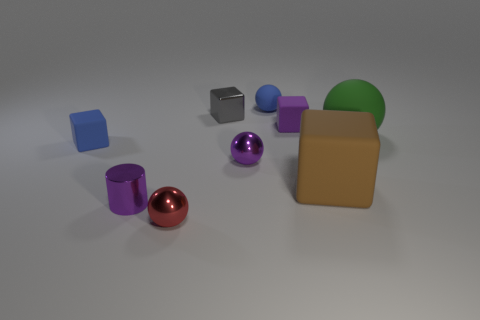Do the gray thing and the purple thing in front of the large brown cube have the same material?
Ensure brevity in your answer.  Yes. Are there fewer rubber cubes than purple matte things?
Keep it short and to the point. No. Is there any other thing that is the same color as the tiny metal cylinder?
Your answer should be very brief. Yes. What shape is the purple object that is the same material as the brown thing?
Offer a very short reply. Cube. There is a ball right of the rubber object that is in front of the purple ball; how many blue balls are in front of it?
Ensure brevity in your answer.  0. There is a rubber thing that is both in front of the green rubber ball and on the left side of the tiny purple rubber cube; what is its shape?
Give a very brief answer. Cube. Is the number of small purple matte cubes that are right of the green rubber thing less than the number of tiny green metal balls?
Provide a succinct answer. No. What number of large things are either brown metallic cylinders or red metal balls?
Your answer should be compact. 0. The metallic cylinder is what size?
Offer a terse response. Small. There is a small gray metallic thing; how many brown matte objects are behind it?
Offer a terse response. 0. 